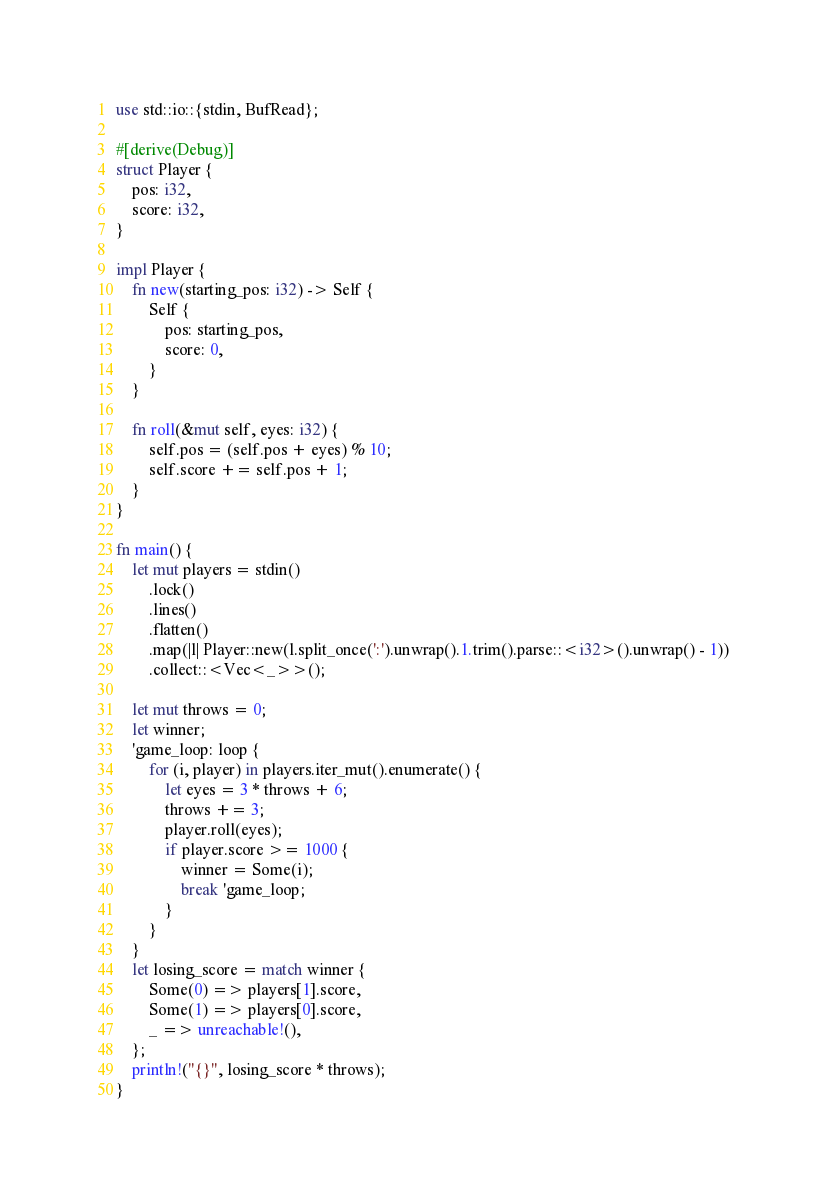Convert code to text. <code><loc_0><loc_0><loc_500><loc_500><_Rust_>use std::io::{stdin, BufRead};

#[derive(Debug)]
struct Player {
    pos: i32,
    score: i32,
}

impl Player {
    fn new(starting_pos: i32) -> Self {
        Self {
            pos: starting_pos,
            score: 0,
        }
    }

    fn roll(&mut self, eyes: i32) {
        self.pos = (self.pos + eyes) % 10;
        self.score += self.pos + 1;
    }
}

fn main() {
    let mut players = stdin()
        .lock()
        .lines()
        .flatten()
        .map(|l| Player::new(l.split_once(':').unwrap().1.trim().parse::<i32>().unwrap() - 1))
        .collect::<Vec<_>>();

    let mut throws = 0;
    let winner;
    'game_loop: loop {
        for (i, player) in players.iter_mut().enumerate() {
            let eyes = 3 * throws + 6;
            throws += 3;
            player.roll(eyes);
            if player.score >= 1000 {
                winner = Some(i);
                break 'game_loop;
            }
        }
    }
    let losing_score = match winner {
        Some(0) => players[1].score,
        Some(1) => players[0].score,
        _ => unreachable!(),
    };
    println!("{}", losing_score * throws);
}
</code> 